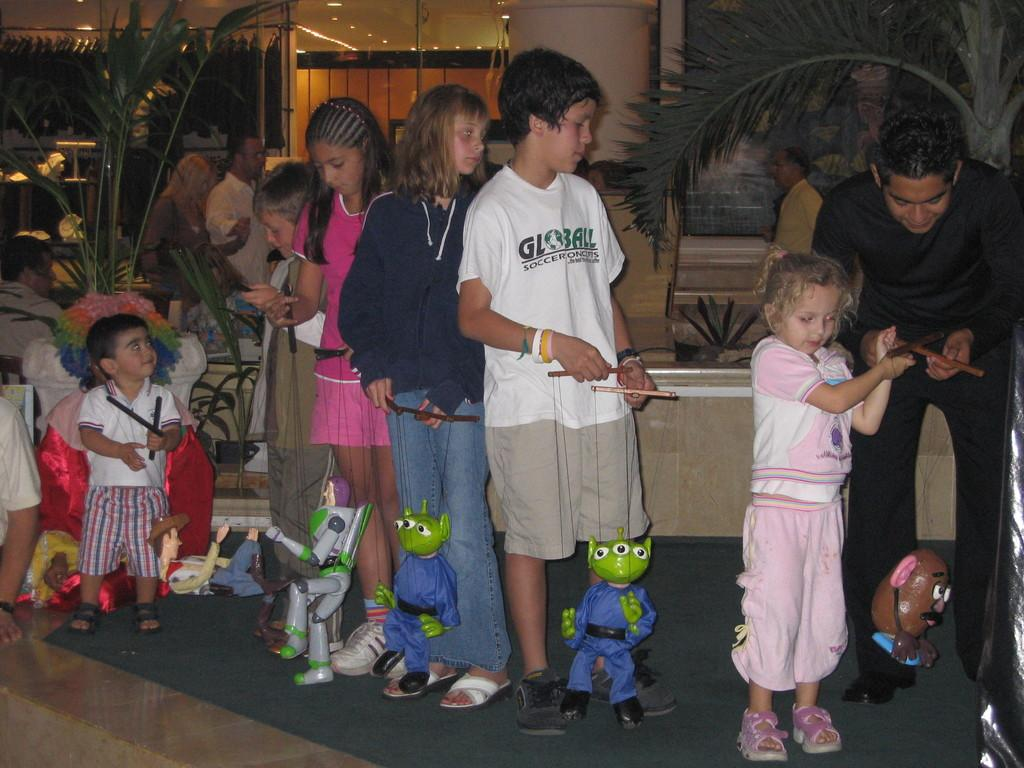How many persons are in the image? There are persons in the image. What else can be seen in the image besides the persons? There are toys in the image. What type of surface is visible in the image? The image shows a floor. What architectural feature can be seen in the background of the image? There is a pillar in the background of the image. What type of vegetation is visible in the background of the image? There are plants in the background of the image. What type of artificial lighting is visible in the background of the image? There are lights in the background of the image. What type of transparent material is visible in the background of the image? There is glass in the background of the image. What type of sofa can be seen smashing through the glass in the image? There is no sofa present in the image, nor is there any indication of a sofa smashing through the glass. 